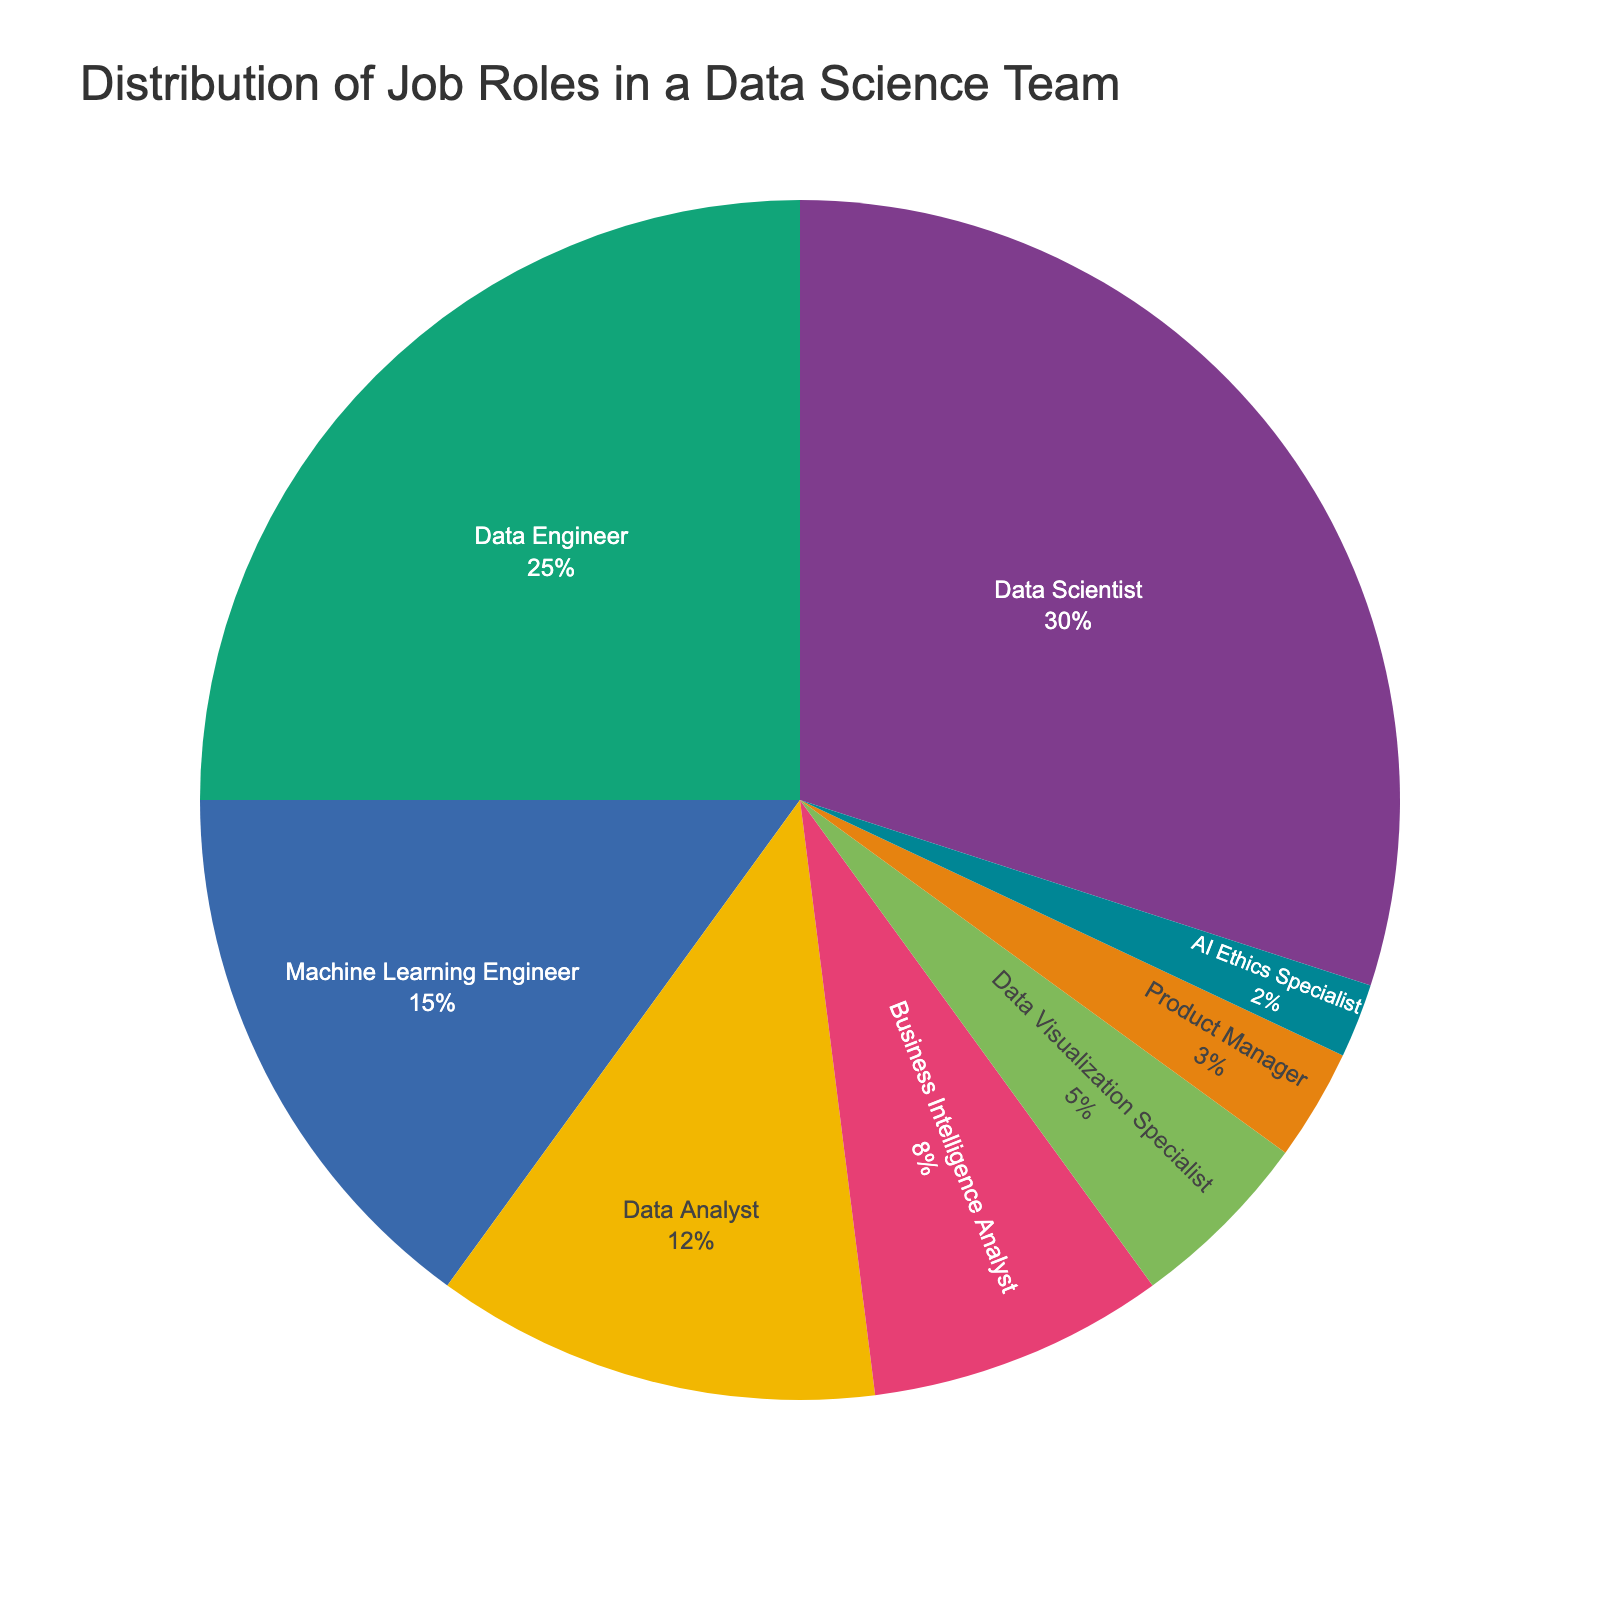What's the most common job role in the data science team? The pie chart shows different job roles by percentage. The largest segment belongs to the Data Scientist role, covering 30% of the team composition.
Answer: Data Scientist What's the combined percentage of Data Engineers and Machine Learning Engineers? The pie chart shows that Data Engineers make up 25% and Machine Learning Engineers make up 15% of the team. Their combined percentage is 25% + 15% = 40%.
Answer: 40% Which roles together make up exactly half of the team? By examining the pie chart, we see Data Scientist (30%) and Data Engineer (25%). Together, their percentages add up to 30% + 25% = 55%, which is more than half. The next major roles are Machine Learning Engineer (15%) and Data Analyst (12%). Combining these two gives 15% + 12% = 27%. Therefore, 27% + 25% = 52% which is also more than half. So the largest contributing roles can't be combined to exactly half. However, collectively, Data Scientist, Data Engineer, and Machine Learning Engineer cover a substantial 70%, which can be considered close to three-quarters of the pie.
Answer: No exact half combination, but Data Scientist and Data Engineer almost (55%) Which job role is represented by the smallest segment? The pie chart indicates that AI Ethics Specialist comprises 2% of the team, the smallest segment.
Answer: AI Ethics Specialist Compare the percentages of Data Analyst and Data Visualization Specialist. Which role is bigger, and by how much? The pie chart shows Data Analyst at 12% and Data Visualization Specialist at 5%. The difference between them is 12% - 5% = 7%. Therefore, Data Analyst is the bigger role by 7%.
Answer: Data Analyst by 7% Is there a role that doubles the percentage of the Product Manager role? If so, which one? The Product Manager role is 3%. Looking at the pie chart, Business Intelligence Analyst is 8%, which is more than double. The role that matches exactly twice the Product Manager role is the Data Visualization Specialist at 5%, close to double.
Answer: Data Visualization Specialist How many roles together contribute to less than 10% of the team? The pie chart shows roles and their corresponding percentages. Business Intelligence Analyst (8%), Data Visualization Specialist (5%), Product Manager (3%), and AI Ethics Specialist (2%) all fit this criterion. Counting them, there are 4 roles.
Answer: 4 If the percentage of Data Scientists were to decrease by 5%, which role would then become the largest? Currently, Data Scientists make up 30%. If this decreases by 5%, it becomes 30% - 5% = 25%. The next highest percentage on the pie chart is Data Engineer at 25%. Thus, they would be tied as the largest role after the decrease.
Answer: Data Engineer and Data Scientist What is the difference in percentage between the Business Intelligence Analyst and the Data Engineer role? According to the pie chart, the Data Engineer role is 25%, and the Business Intelligence Analyst role is 8%. The difference is 25% - 8% = 17%.
Answer: 17% 